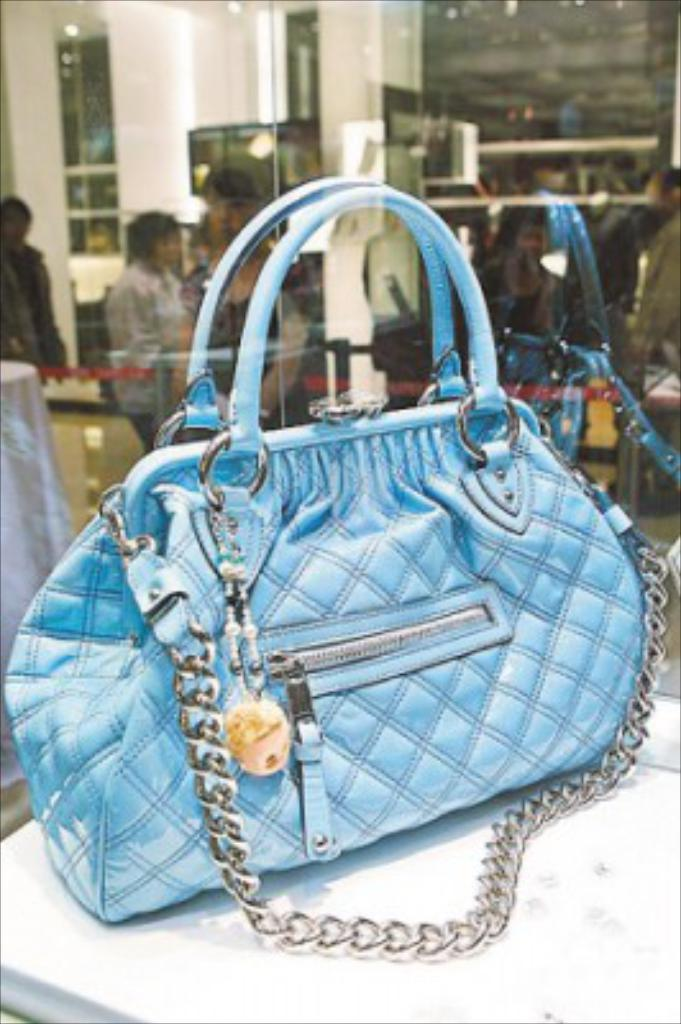What object is on the table in the image? There is a bag on the table in the image. Can you describe the people in the image? Unfortunately, the facts provided do not give any information about the people in the image. What type of lettuce is being used as a whistle by the fireman in the image? There is no fireman or lettuce present in the image. 